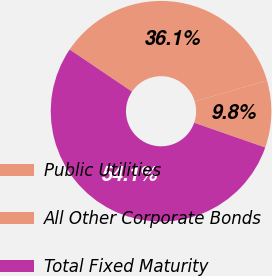<chart> <loc_0><loc_0><loc_500><loc_500><pie_chart><fcel>Public Utilities<fcel>All Other Corporate Bonds<fcel>Total Fixed Maturity<nl><fcel>9.82%<fcel>36.06%<fcel>54.12%<nl></chart> 